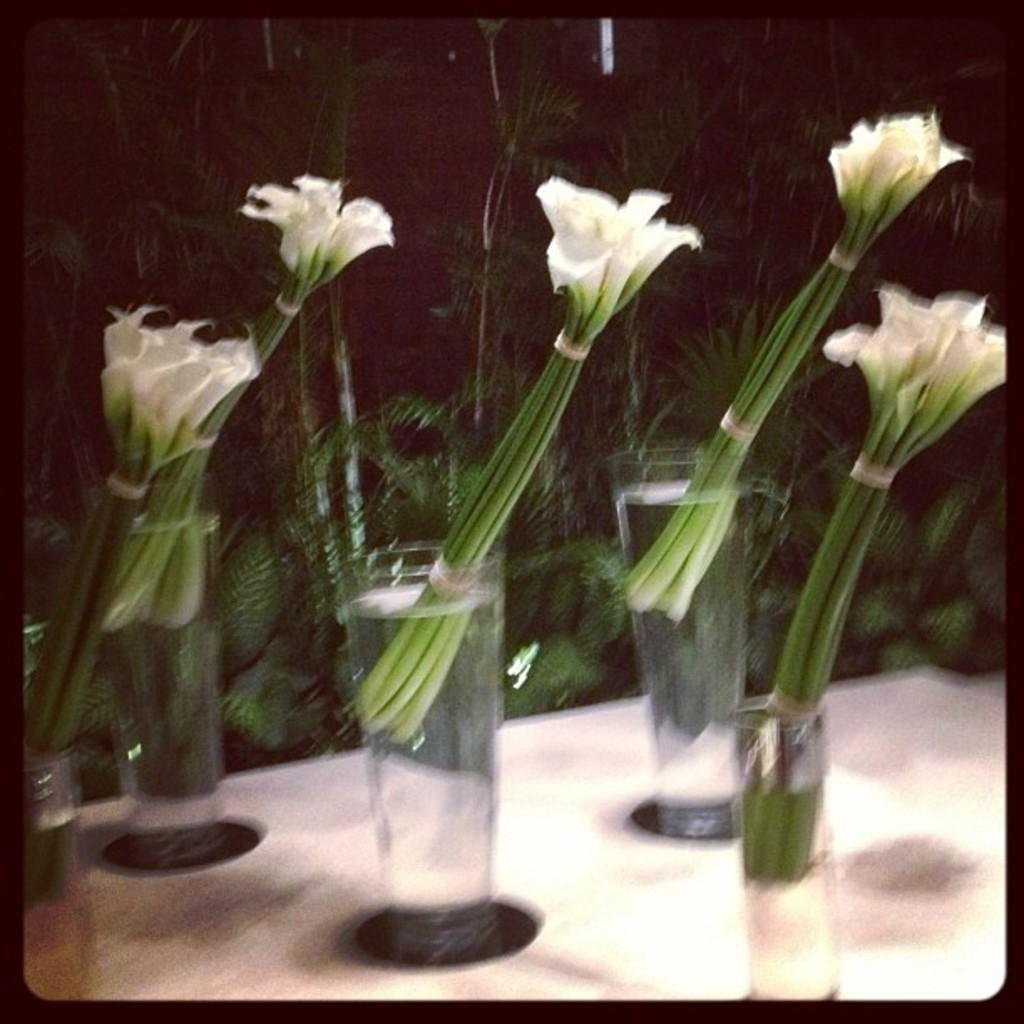Could you give a brief overview of what you see in this image? In this image, I can see five bunches of flowers, which are kept in a glass of water. These glasses are placed on the table. In the background, I can see the trees. 